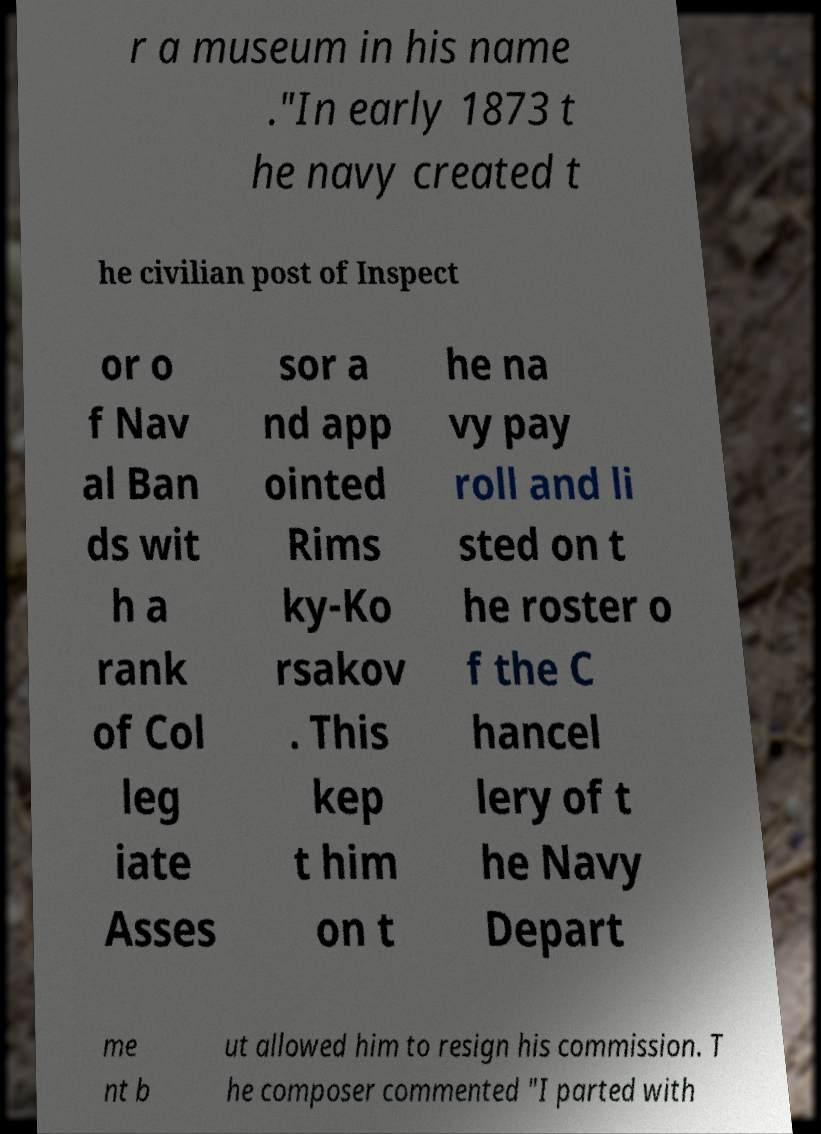Please read and relay the text visible in this image. What does it say? r a museum in his name ."In early 1873 t he navy created t he civilian post of Inspect or o f Nav al Ban ds wit h a rank of Col leg iate Asses sor a nd app ointed Rims ky-Ko rsakov . This kep t him on t he na vy pay roll and li sted on t he roster o f the C hancel lery of t he Navy Depart me nt b ut allowed him to resign his commission. T he composer commented "I parted with 